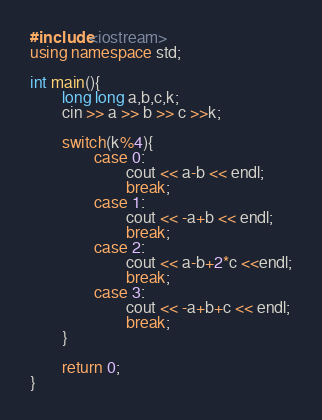<code> <loc_0><loc_0><loc_500><loc_500><_C++_>#include<iostream>
using namespace std;

int main(){
        long long a,b,c,k;
        cin >> a >> b >> c >>k;

        switch(k%4){
                case 0:
                        cout << a-b << endl;
                        break;
                case 1:
                        cout << -a+b << endl;
                        break;
                case 2:
                        cout << a-b+2*c <<endl;
                        break;
                case 3:
                        cout << -a+b+c << endl;
                        break;
        }

        return 0;
}</code> 